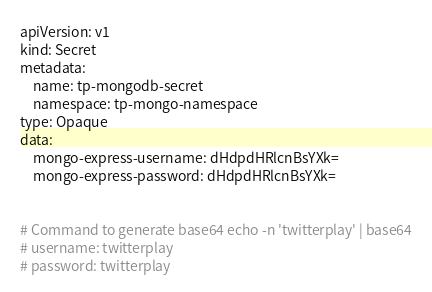<code> <loc_0><loc_0><loc_500><loc_500><_YAML_>apiVersion: v1
kind: Secret
metadata:
    name: tp-mongodb-secret
    namespace: tp-mongo-namespace
type: Opaque
data:
    mongo-express-username: dHdpdHRlcnBsYXk=
    mongo-express-password: dHdpdHRlcnBsYXk=


# Command to generate base64 echo -n 'twitterplay' | base64
# username: twitterplay
# password: twitterplay
</code> 